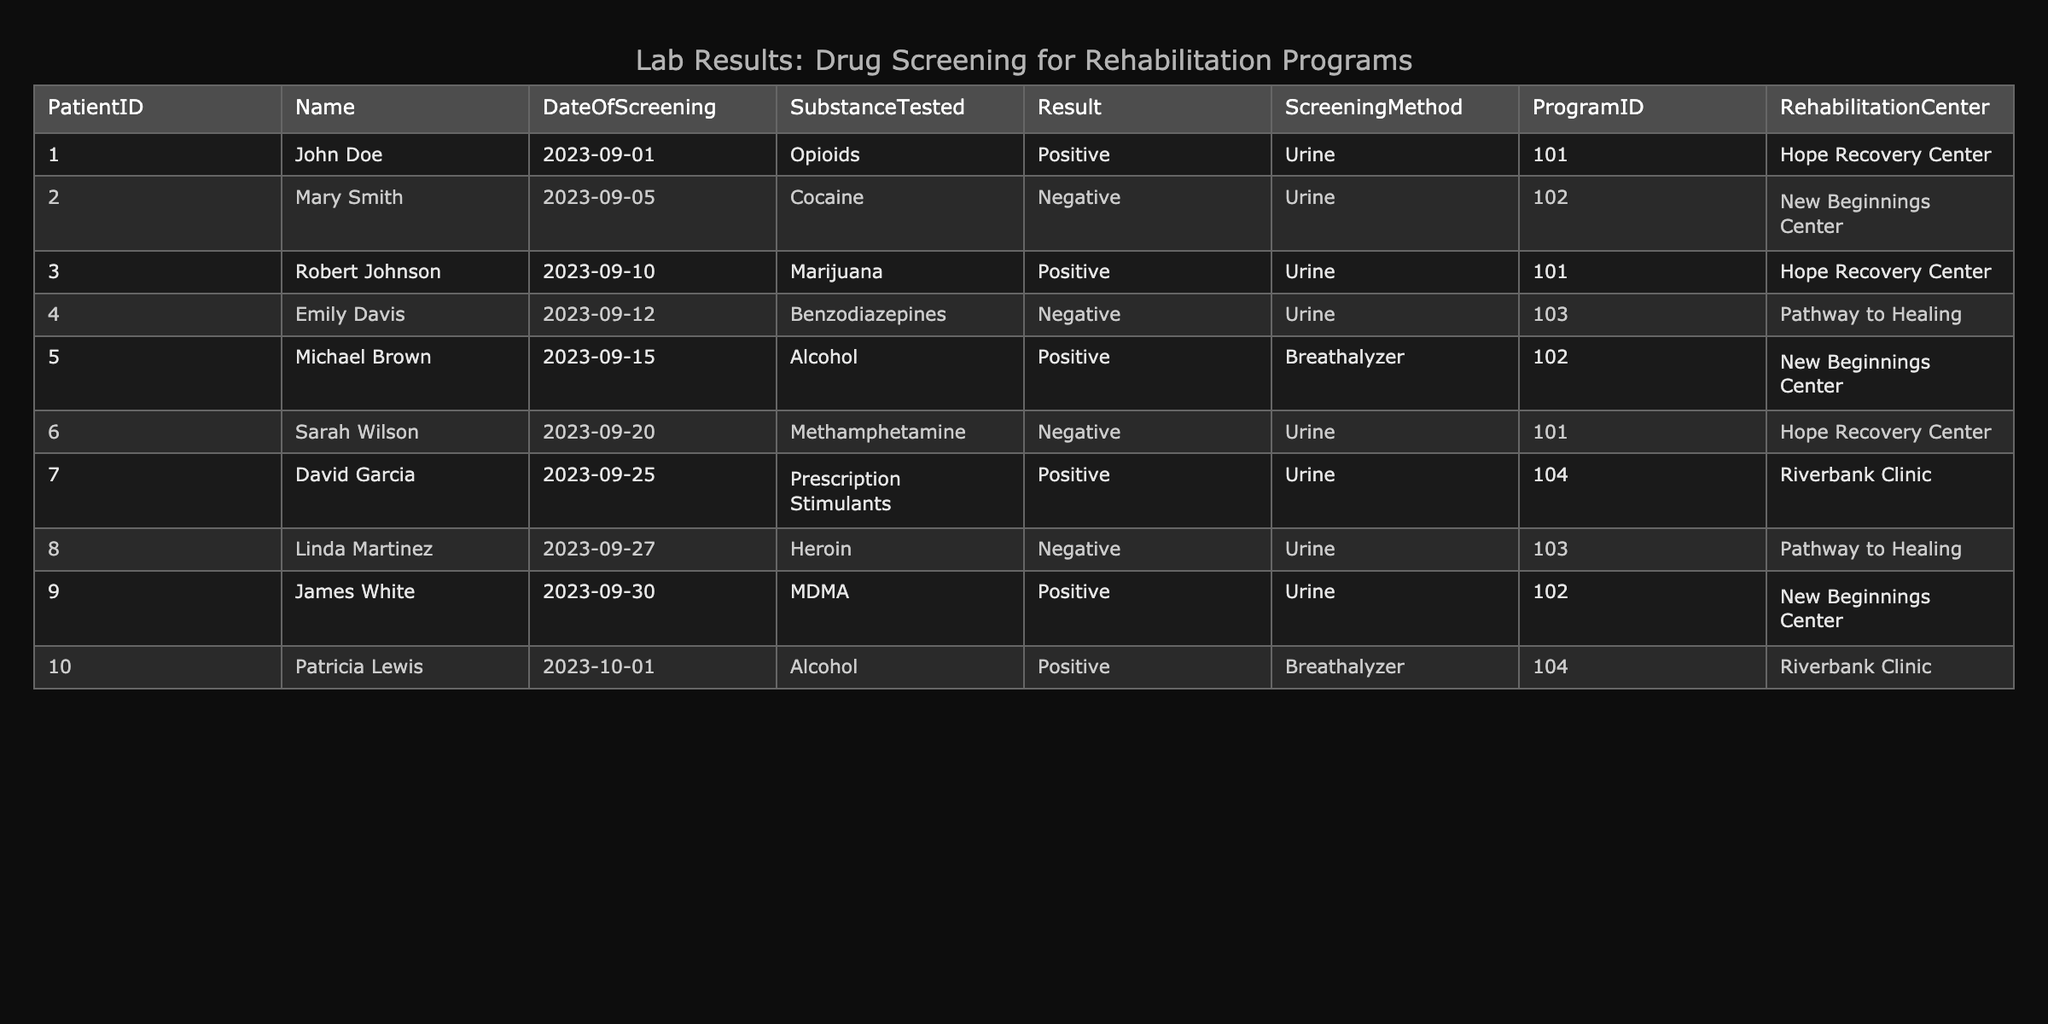What substance was tested for John Doe? By looking at the row corresponding to John Doe in the table, we see that the substance tested is Opioids.
Answer: Opioids How many patients tested negative for substances in the table? To find the answer, I check the 'Result' column for the screening results of each patient. Counting the rows with a negative result, we find that there are 4 patients (Mary Smith, Emily Davis, Sarah Wilson, and Linda Martinez).
Answer: 4 Which rehabilitation center had the highest number of positive tests? I analyze the table to count the number of positive results for each rehabilitation center. Hope Recovery Center has 3 positives (John Doe, Robert Johnson, Sarah Wilson), New Beginnings Center has 2 (Michael Brown, James White), and Riverbank Clinic has 2 (David Garcia, Patricia Lewis). Therefore, Hope Recovery Center has the highest number.
Answer: Hope Recovery Center Was there any screening result for Alcohol that was negative? Reviewing the screening result for Alcohol by checking the Substance Tested column for any negative results, we find that both tests for Alcohol (Michael Brown and Patricia Lewis) returned positive results.
Answer: No What is the most common substance tested among the patients in this dataset? By examining the Substance Tested column, I count the frequency of each substance. The substances are: Opioids (1), Cocaine (1), Marijuana (1), Benzodiazepines (1), Alcohol (2), Methamphetamine (1), Prescription Stimulants (1), Heroin (1), MDMA (1). Alcohol occurs most often, with 2 occurrences.
Answer: Alcohol How many unique patients tested positive for any substance? I can determine this by filtering the table for rows marked as 'Positive' in the Result column. The patients with positive tests are John Doe, Robert Johnson, Michael Brown, David Garcia, James White, and Patricia Lewis. This totals to 6 unique patients.
Answer: 6 Did any patient in the Hope Recovery Center test negative for a substance? Checking the entries for the Hope Recovery Center in the table, John Doe tested positive, Robert Johnson tested positive, and Sarah Wilson tested negative. Therefore, at least one patient at this center did test negative.
Answer: Yes Which substance was tested for David Garcia, and what was the result? By finding the row corresponding to David Garcia in the table, I see that the substance tested is Prescription Stimulants, and the result is Positive.
Answer: Prescription Stimulants, Positive How does the number of patients testing positive compare to those testing negative overall? To find this, I total the number of positive results (6 patients) and the number of negative results (4 patients). The positive count is greater than the negative count, which means there are more patients who tested positive than negative.
Answer: More positive than negative 